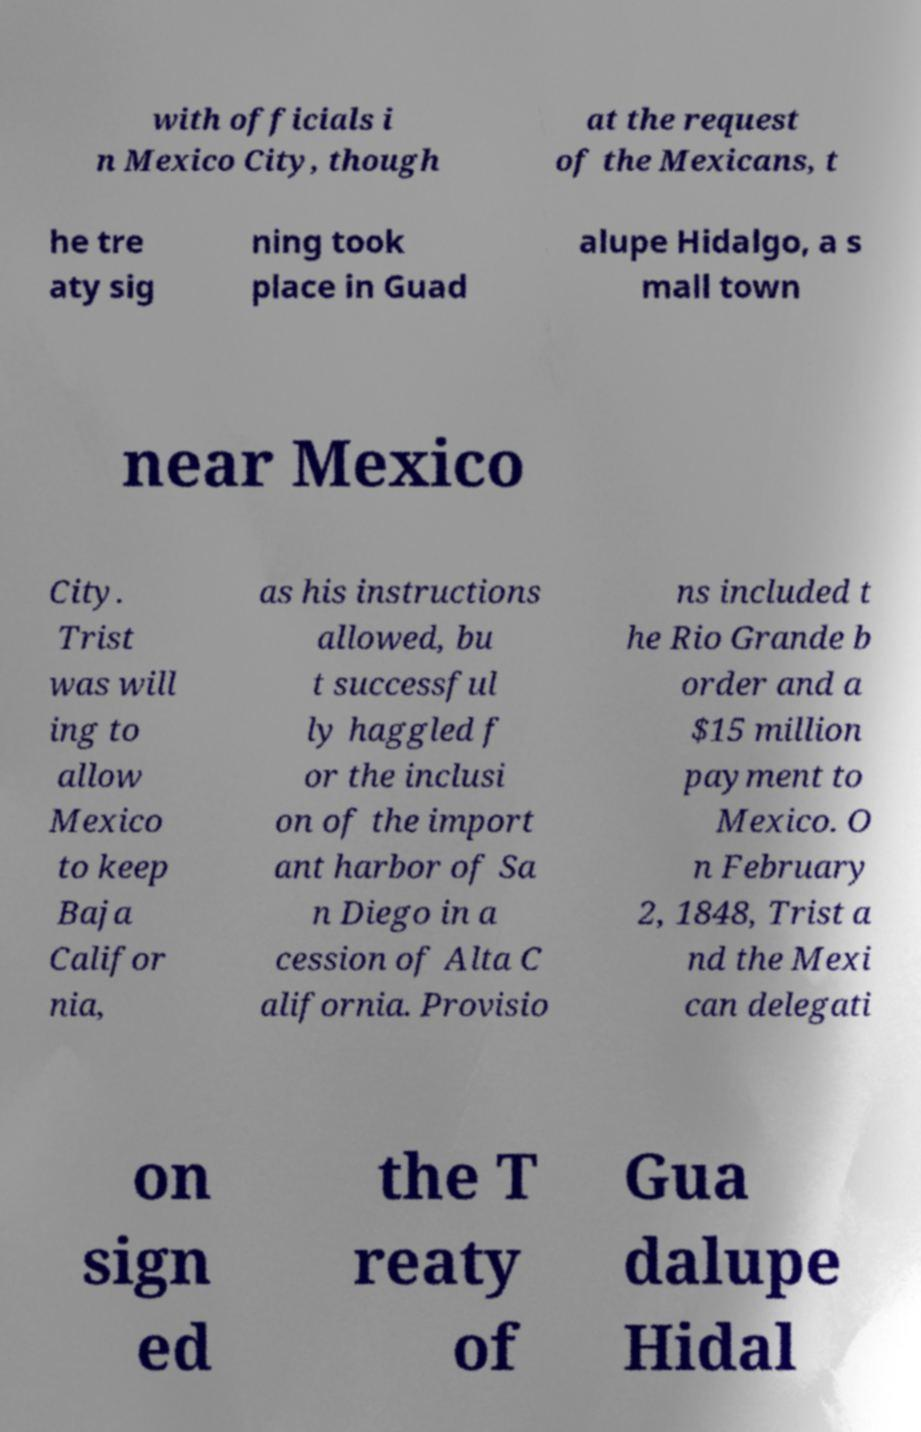Could you assist in decoding the text presented in this image and type it out clearly? with officials i n Mexico City, though at the request of the Mexicans, t he tre aty sig ning took place in Guad alupe Hidalgo, a s mall town near Mexico City. Trist was will ing to allow Mexico to keep Baja Califor nia, as his instructions allowed, bu t successful ly haggled f or the inclusi on of the import ant harbor of Sa n Diego in a cession of Alta C alifornia. Provisio ns included t he Rio Grande b order and a $15 million payment to Mexico. O n February 2, 1848, Trist a nd the Mexi can delegati on sign ed the T reaty of Gua dalupe Hidal 